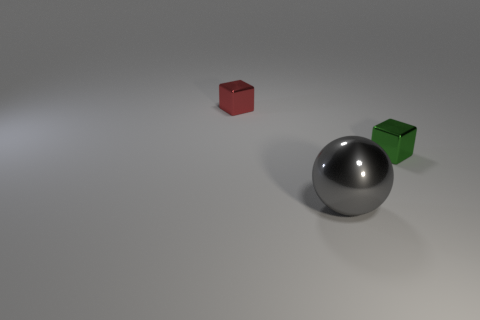Add 2 brown spheres. How many objects exist? 5 Subtract all red cubes. How many cubes are left? 1 Subtract all spheres. How many objects are left? 2 Subtract 1 balls. How many balls are left? 0 Subtract all small green things. Subtract all cyan things. How many objects are left? 2 Add 1 big things. How many big things are left? 2 Add 2 tiny red shiny things. How many tiny red shiny things exist? 3 Subtract 0 brown cubes. How many objects are left? 3 Subtract all yellow cubes. Subtract all purple spheres. How many cubes are left? 2 Subtract all green spheres. How many red cubes are left? 1 